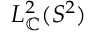<formula> <loc_0><loc_0><loc_500><loc_500>L _ { \mathbb { C } } ^ { 2 } ( S ^ { 2 } )</formula> 